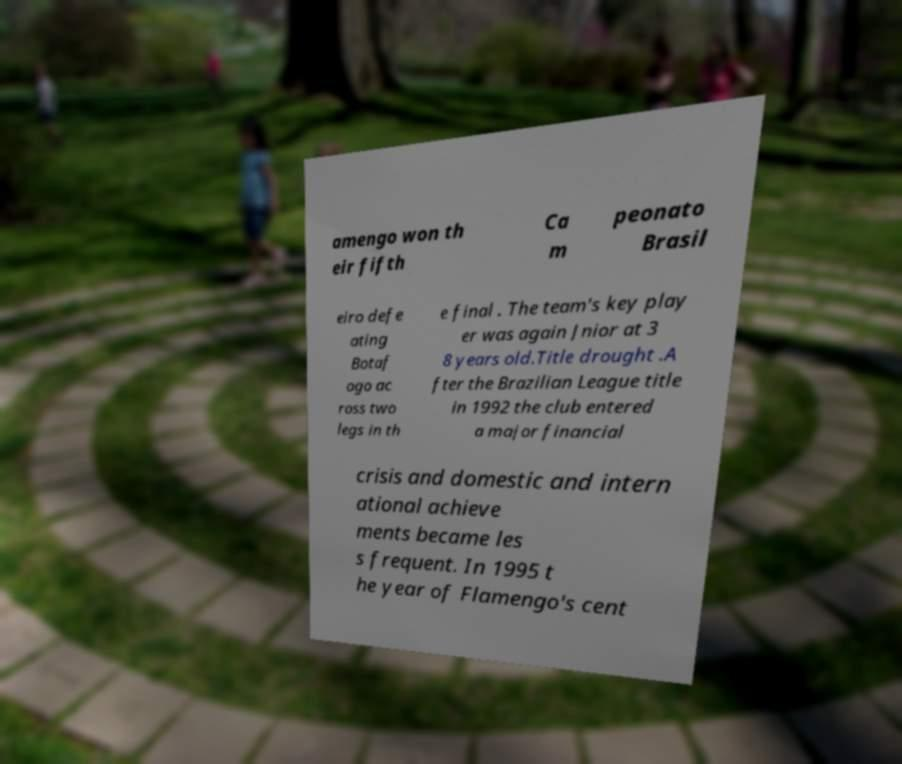Could you assist in decoding the text presented in this image and type it out clearly? amengo won th eir fifth Ca m peonato Brasil eiro defe ating Botaf ogo ac ross two legs in th e final . The team's key play er was again Jnior at 3 8 years old.Title drought .A fter the Brazilian League title in 1992 the club entered a major financial crisis and domestic and intern ational achieve ments became les s frequent. In 1995 t he year of Flamengo's cent 